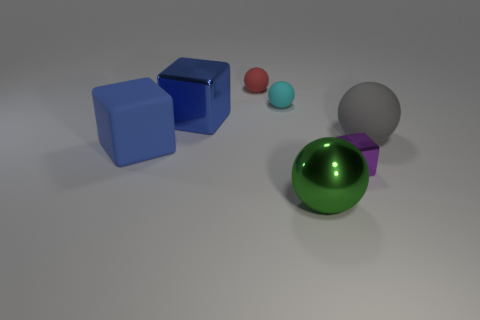Subtract 1 blocks. How many blocks are left? 2 Subtract all yellow balls. Subtract all blue cubes. How many balls are left? 4 Add 1 shiny blocks. How many objects exist? 8 Subtract all balls. How many objects are left? 3 Subtract all big purple things. Subtract all big gray matte spheres. How many objects are left? 6 Add 6 big gray matte things. How many big gray matte things are left? 7 Add 2 small blue matte balls. How many small blue matte balls exist? 2 Subtract 1 gray balls. How many objects are left? 6 